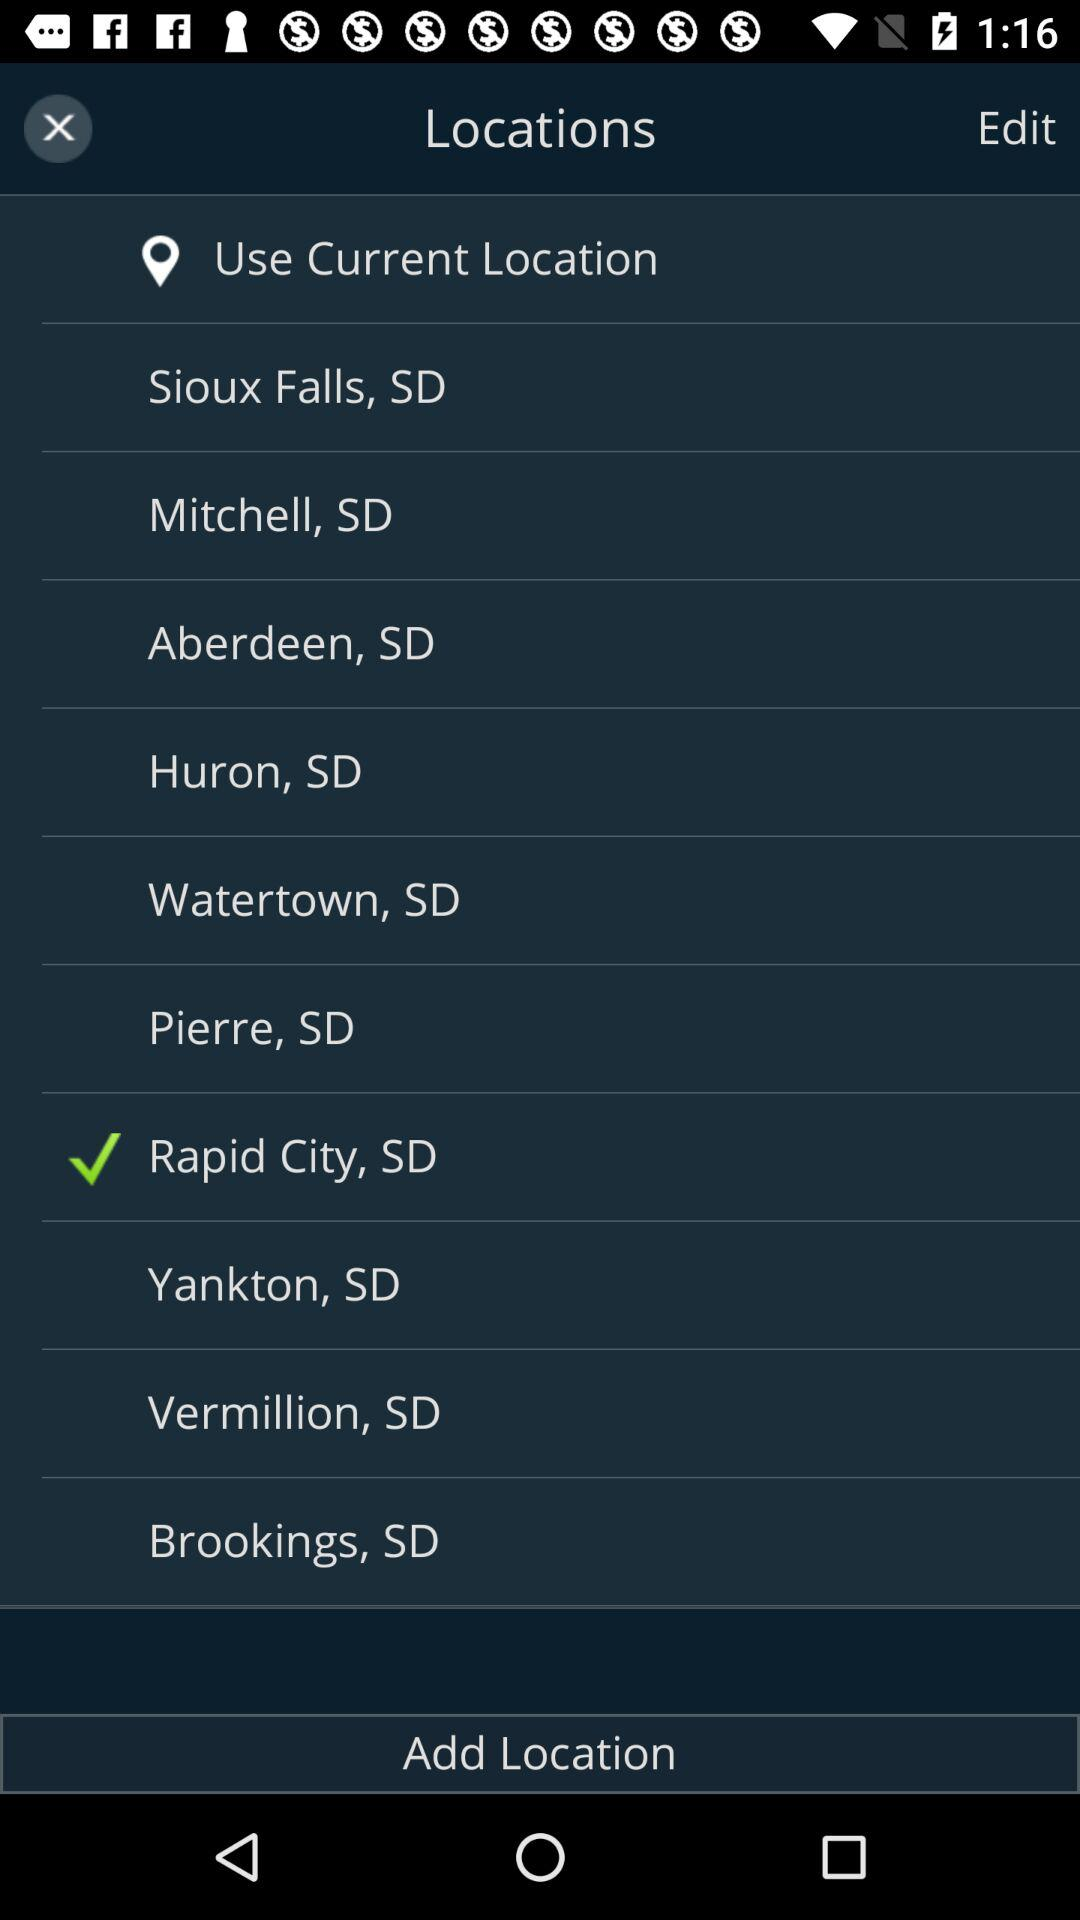Which option is selected? The selected option is "Rapid City, SD". 